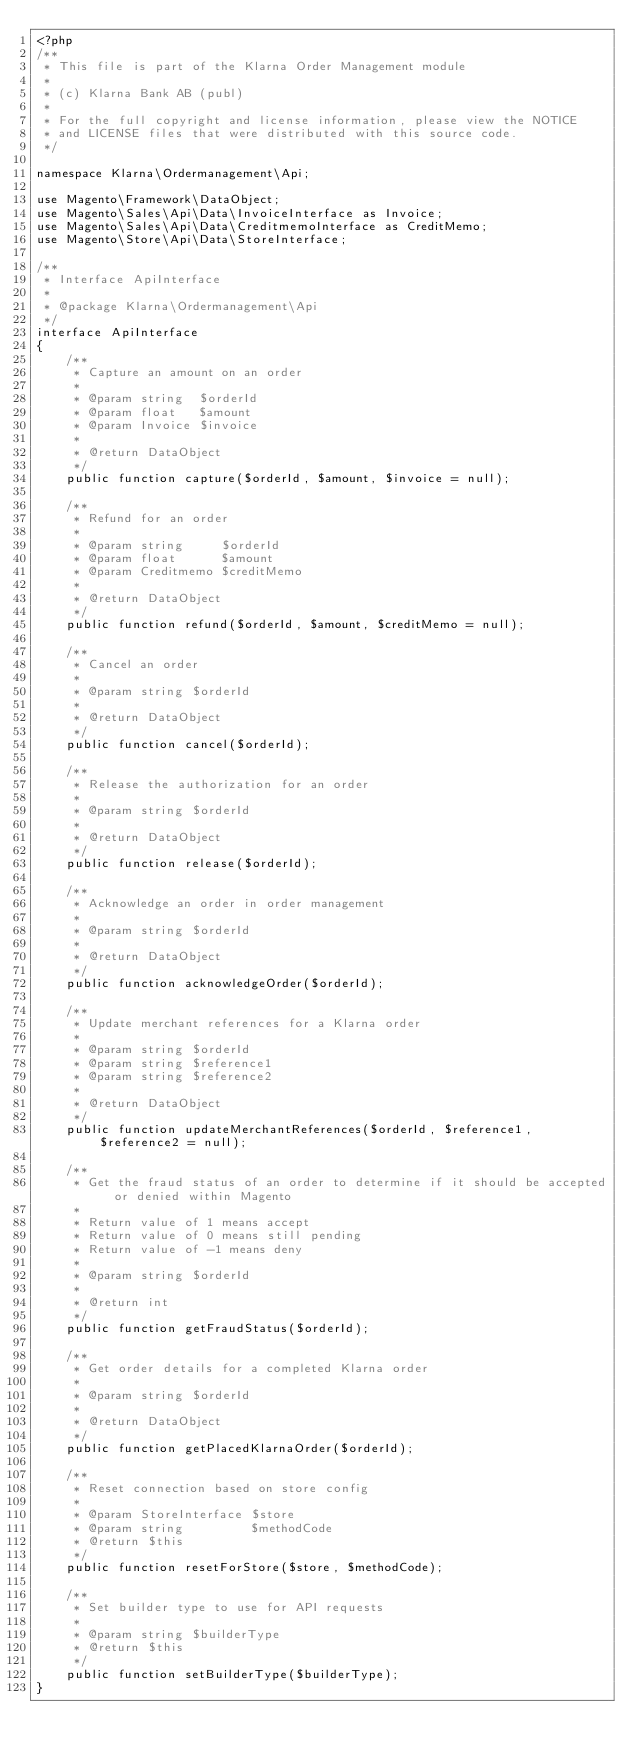<code> <loc_0><loc_0><loc_500><loc_500><_PHP_><?php
/**
 * This file is part of the Klarna Order Management module
 *
 * (c) Klarna Bank AB (publ)
 *
 * For the full copyright and license information, please view the NOTICE
 * and LICENSE files that were distributed with this source code.
 */

namespace Klarna\Ordermanagement\Api;

use Magento\Framework\DataObject;
use Magento\Sales\Api\Data\InvoiceInterface as Invoice;
use Magento\Sales\Api\Data\CreditmemoInterface as CreditMemo;
use Magento\Store\Api\Data\StoreInterface;

/**
 * Interface ApiInterface
 *
 * @package Klarna\Ordermanagement\Api
 */
interface ApiInterface
{
    /**
     * Capture an amount on an order
     *
     * @param string  $orderId
     * @param float   $amount
     * @param Invoice $invoice
     *
     * @return DataObject
     */
    public function capture($orderId, $amount, $invoice = null);

    /**
     * Refund for an order
     *
     * @param string     $orderId
     * @param float      $amount
     * @param Creditmemo $creditMemo
     *
     * @return DataObject
     */
    public function refund($orderId, $amount, $creditMemo = null);

    /**
     * Cancel an order
     *
     * @param string $orderId
     *
     * @return DataObject
     */
    public function cancel($orderId);

    /**
     * Release the authorization for an order
     *
     * @param string $orderId
     *
     * @return DataObject
     */
    public function release($orderId);

    /**
     * Acknowledge an order in order management
     *
     * @param string $orderId
     *
     * @return DataObject
     */
    public function acknowledgeOrder($orderId);

    /**
     * Update merchant references for a Klarna order
     *
     * @param string $orderId
     * @param string $reference1
     * @param string $reference2
     *
     * @return DataObject
     */
    public function updateMerchantReferences($orderId, $reference1, $reference2 = null);

    /**
     * Get the fraud status of an order to determine if it should be accepted or denied within Magento
     *
     * Return value of 1 means accept
     * Return value of 0 means still pending
     * Return value of -1 means deny
     *
     * @param string $orderId
     *
     * @return int
     */
    public function getFraudStatus($orderId);

    /**
     * Get order details for a completed Klarna order
     *
     * @param string $orderId
     *
     * @return DataObject
     */
    public function getPlacedKlarnaOrder($orderId);

    /**
     * Reset connection based on store config
     *
     * @param StoreInterface $store
     * @param string         $methodCode
     * @return $this
     */
    public function resetForStore($store, $methodCode);

    /**
     * Set builder type to use for API requests
     *
     * @param string $builderType
     * @return $this
     */
    public function setBuilderType($builderType);
}
</code> 